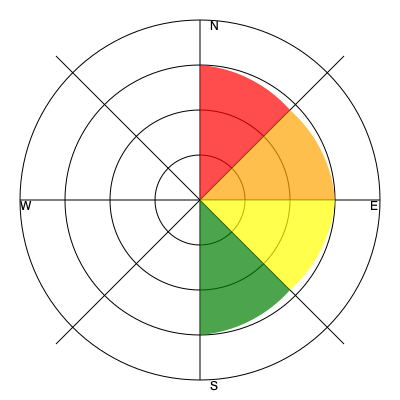Based on the wind rose diagram, which direction is most likely to experience the highest concentration of smoke during a controlled burn? To interpret the wind rose diagram and determine the direction most likely to experience the highest concentration of smoke during a controlled burn, follow these steps:

1. Understand the diagram:
   - The circular diagram represents wind directions.
   - The colored sections indicate wind frequency and speed from different directions.
   - Larger and darker colored sections represent stronger and more frequent winds.

2. Analyze the colored sections:
   - Red (NE): Largest section, indicating most frequent and strongest winds.
   - Orange (SE): Second largest section.
   - Yellow (SW): Third largest section.
   - Green (NW): Smallest section, indicating least frequent and weakest winds.

3. Consider smoke behavior:
   - Smoke from controlled burns typically follows the prevailing wind direction.
   - Stronger winds carry smoke further and disperse it more quickly.

4. Determine the most affected direction:
   - The direction opposite to the strongest winds will experience the highest smoke concentration.
   - The red section (NE) represents the strongest and most frequent winds.
   - Therefore, the opposite direction (SW) will likely experience the highest smoke concentration.

5. Conclusion:
   The southwestern (SW) direction is most likely to experience the highest concentration of smoke during a controlled burn, as it is downwind from the strongest and most frequent winds coming from the northeast (NE).
Answer: Southwest (SW) 